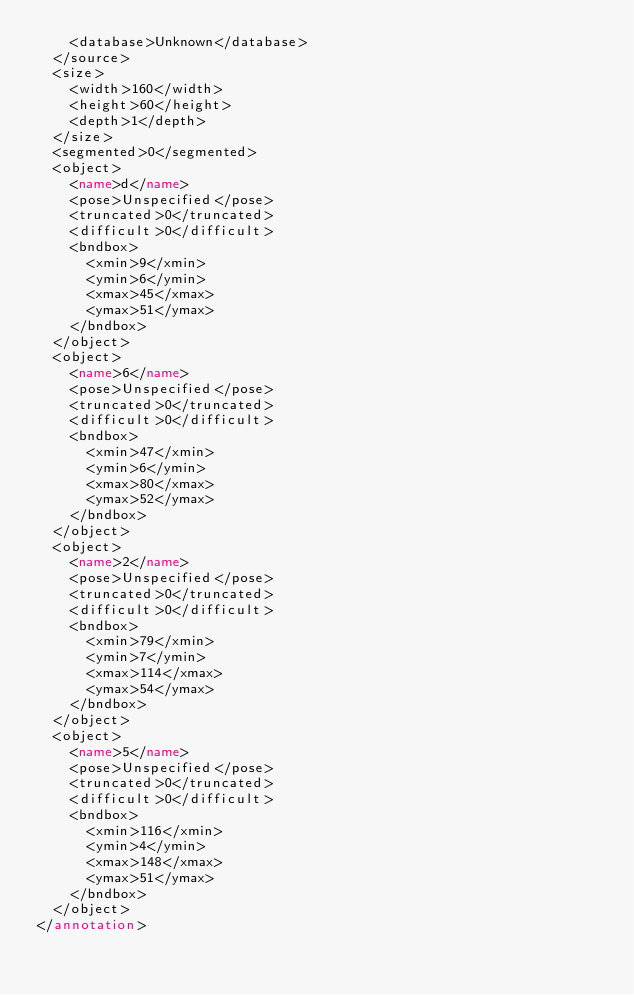Convert code to text. <code><loc_0><loc_0><loc_500><loc_500><_XML_>		<database>Unknown</database>
	</source>
	<size>
		<width>160</width>
		<height>60</height>
		<depth>1</depth>
	</size>
	<segmented>0</segmented>
	<object>
		<name>d</name>
		<pose>Unspecified</pose>
		<truncated>0</truncated>
		<difficult>0</difficult>
		<bndbox>
			<xmin>9</xmin>
			<ymin>6</ymin>
			<xmax>45</xmax>
			<ymax>51</ymax>
		</bndbox>
	</object>
	<object>
		<name>6</name>
		<pose>Unspecified</pose>
		<truncated>0</truncated>
		<difficult>0</difficult>
		<bndbox>
			<xmin>47</xmin>
			<ymin>6</ymin>
			<xmax>80</xmax>
			<ymax>52</ymax>
		</bndbox>
	</object>
	<object>
		<name>2</name>
		<pose>Unspecified</pose>
		<truncated>0</truncated>
		<difficult>0</difficult>
		<bndbox>
			<xmin>79</xmin>
			<ymin>7</ymin>
			<xmax>114</xmax>
			<ymax>54</ymax>
		</bndbox>
	</object>
	<object>
		<name>5</name>
		<pose>Unspecified</pose>
		<truncated>0</truncated>
		<difficult>0</difficult>
		<bndbox>
			<xmin>116</xmin>
			<ymin>4</ymin>
			<xmax>148</xmax>
			<ymax>51</ymax>
		</bndbox>
	</object>
</annotation>
</code> 